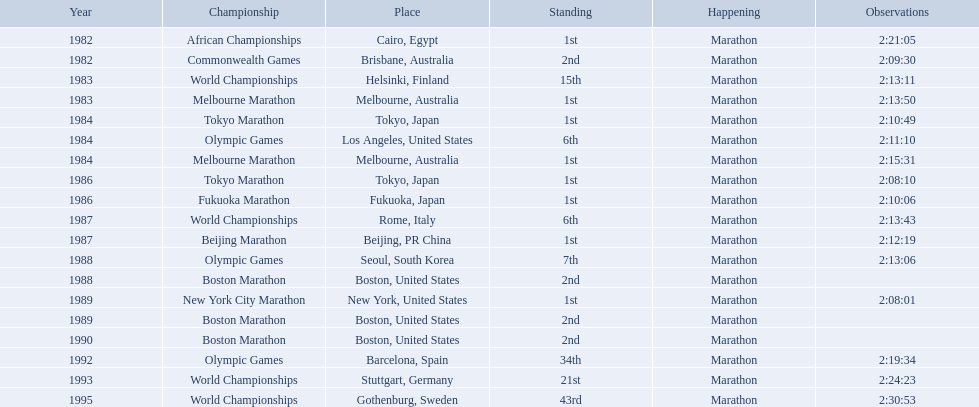What are all of the juma ikangaa competitions? African Championships, Commonwealth Games, World Championships, Melbourne Marathon, Tokyo Marathon, Olympic Games, Melbourne Marathon, Tokyo Marathon, Fukuoka Marathon, World Championships, Beijing Marathon, Olympic Games, Boston Marathon, New York City Marathon, Boston Marathon, Boston Marathon, Olympic Games, World Championships, World Championships. Which of these competitions did not take place in the united states? African Championships, Commonwealth Games, World Championships, Melbourne Marathon, Tokyo Marathon, Melbourne Marathon, Tokyo Marathon, Fukuoka Marathon, World Championships, Beijing Marathon, Olympic Games, Olympic Games, World Championships, World Championships. Out of these, which of them took place in asia? Tokyo Marathon, Tokyo Marathon, Fukuoka Marathon, Beijing Marathon, Olympic Games. Which of the remaining competitions took place in china? Beijing Marathon. 